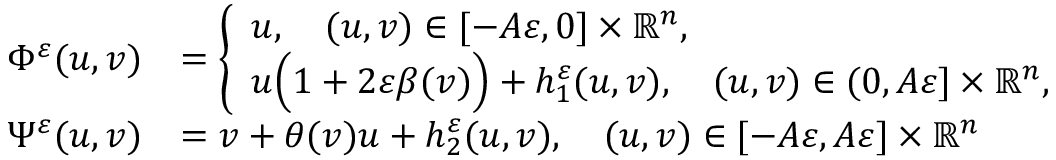Convert formula to latex. <formula><loc_0><loc_0><loc_500><loc_500>\begin{array} { r l } { \Phi ^ { \varepsilon } ( u , v ) } & { = \left \{ \begin{array} { l l } { u , \quad ( u , v ) \in [ - A \varepsilon , 0 ] \times \mathbb { R } ^ { n } , } \\ { u \left ( 1 + 2 \varepsilon \beta ( v ) \right ) + h _ { 1 } ^ { \varepsilon } ( u , v ) , \quad ( u , v ) \in ( 0 , A \varepsilon ] \times \mathbb { R } ^ { n } , } \end{array} } \\ { \Psi ^ { \varepsilon } ( u , v ) } & { = v + \theta ( v ) u + h _ { 2 } ^ { \varepsilon } ( u , v ) , \quad ( u , v ) \in [ - A \varepsilon , A \varepsilon ] \times \mathbb { R } ^ { n } } \end{array}</formula> 